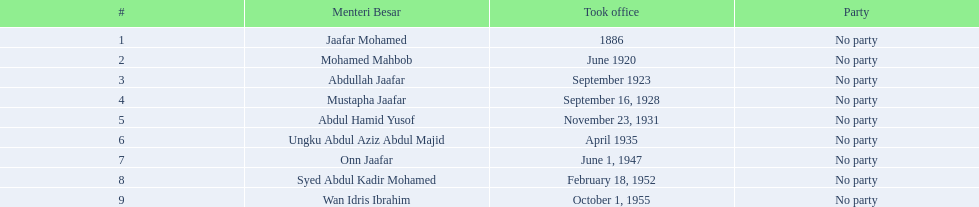When did jaafar mohamed take office? 1886. When did mohamed mahbob take office? June 1920. Who was in office no more than 4 years? Mohamed Mahbob. 